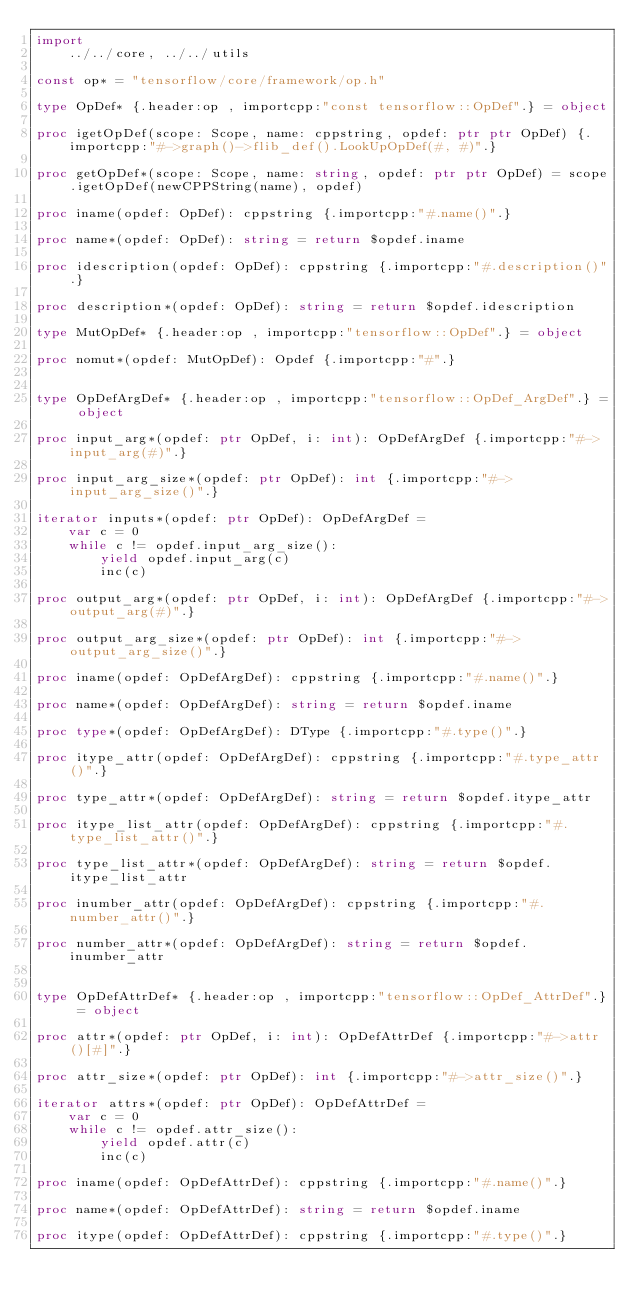<code> <loc_0><loc_0><loc_500><loc_500><_Nim_>import 
    ../../core, ../../utils

const op* = "tensorflow/core/framework/op.h"

type OpDef* {.header:op , importcpp:"const tensorflow::OpDef".} = object

proc igetOpDef(scope: Scope, name: cppstring, opdef: ptr ptr OpDef) {.importcpp:"#->graph()->flib_def().LookUpOpDef(#, #)".}

proc getOpDef*(scope: Scope, name: string, opdef: ptr ptr OpDef) = scope.igetOpDef(newCPPString(name), opdef)

proc iname(opdef: OpDef): cppstring {.importcpp:"#.name()".}

proc name*(opdef: OpDef): string = return $opdef.iname

proc idescription(opdef: OpDef): cppstring {.importcpp:"#.description()".}

proc description*(opdef: OpDef): string = return $opdef.idescription

type MutOpDef* {.header:op , importcpp:"tensorflow::OpDef".} = object

proc nomut*(opdef: MutOpDef): Opdef {.importcpp:"#".}


type OpDefArgDef* {.header:op , importcpp:"tensorflow::OpDef_ArgDef".} = object

proc input_arg*(opdef: ptr OpDef, i: int): OpDefArgDef {.importcpp:"#->input_arg(#)".}

proc input_arg_size*(opdef: ptr OpDef): int {.importcpp:"#->input_arg_size()".}

iterator inputs*(opdef: ptr OpDef): OpDefArgDef =
    var c = 0
    while c != opdef.input_arg_size():
        yield opdef.input_arg(c)
        inc(c)

proc output_arg*(opdef: ptr OpDef, i: int): OpDefArgDef {.importcpp:"#->output_arg(#)".}

proc output_arg_size*(opdef: ptr OpDef): int {.importcpp:"#->output_arg_size()".}

proc iname(opdef: OpDefArgDef): cppstring {.importcpp:"#.name()".}

proc name*(opdef: OpDefArgDef): string = return $opdef.iname

proc type*(opdef: OpDefArgDef): DType {.importcpp:"#.type()".}

proc itype_attr(opdef: OpDefArgDef): cppstring {.importcpp:"#.type_attr()".}

proc type_attr*(opdef: OpDefArgDef): string = return $opdef.itype_attr

proc itype_list_attr(opdef: OpDefArgDef): cppstring {.importcpp:"#.type_list_attr()".}

proc type_list_attr*(opdef: OpDefArgDef): string = return $opdef.itype_list_attr

proc inumber_attr(opdef: OpDefArgDef): cppstring {.importcpp:"#.number_attr()".}

proc number_attr*(opdef: OpDefArgDef): string = return $opdef.inumber_attr


type OpDefAttrDef* {.header:op , importcpp:"tensorflow::OpDef_AttrDef".} = object

proc attr*(opdef: ptr OpDef, i: int): OpDefAttrDef {.importcpp:"#->attr()[#]".}

proc attr_size*(opdef: ptr OpDef): int {.importcpp:"#->attr_size()".}

iterator attrs*(opdef: ptr OpDef): OpDefAttrDef =
    var c = 0
    while c != opdef.attr_size():
        yield opdef.attr(c)
        inc(c)

proc iname(opdef: OpDefAttrDef): cppstring {.importcpp:"#.name()".}

proc name*(opdef: OpDefAttrDef): string = return $opdef.iname

proc itype(opdef: OpDefAttrDef): cppstring {.importcpp:"#.type()".}
</code> 